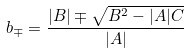Convert formula to latex. <formula><loc_0><loc_0><loc_500><loc_500>b _ { \mp } = \frac { | B | \mp \sqrt { B ^ { 2 } - | A | C } } { | A | }</formula> 